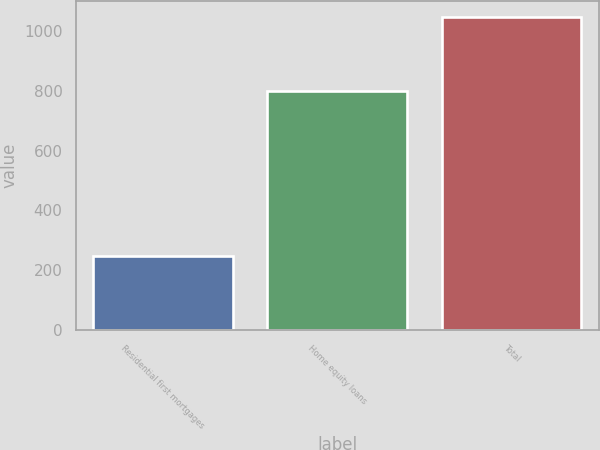<chart> <loc_0><loc_0><loc_500><loc_500><bar_chart><fcel>Residential first mortgages<fcel>Home equity loans<fcel>Total<nl><fcel>247<fcel>800<fcel>1047<nl></chart> 